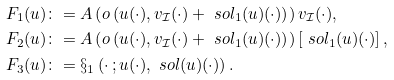Convert formula to latex. <formula><loc_0><loc_0><loc_500><loc_500>F _ { 1 } ( u ) & \colon = A \left ( o \left ( u ( \cdot ) , v _ { \mathcal { I } } ( \cdot ) + \ s o l _ { 1 } ( u ) ( \cdot ) \right ) \right ) v _ { \mathcal { I } } ( \cdot ) , \\ F _ { 2 } ( u ) & \colon = A \left ( o \left ( u ( \cdot ) , v _ { \mathcal { I } } ( \cdot ) + \ s o l _ { 1 } ( u ) ( \cdot ) \right ) \right ) \left [ \ s o l _ { 1 } ( u ) ( \cdot ) \right ] , \\ F _ { 3 } ( u ) & \colon = \S _ { 1 } \left ( \cdot \, ; u ( \cdot ) , \ s o l ( u ) ( \cdot ) \right ) .</formula> 